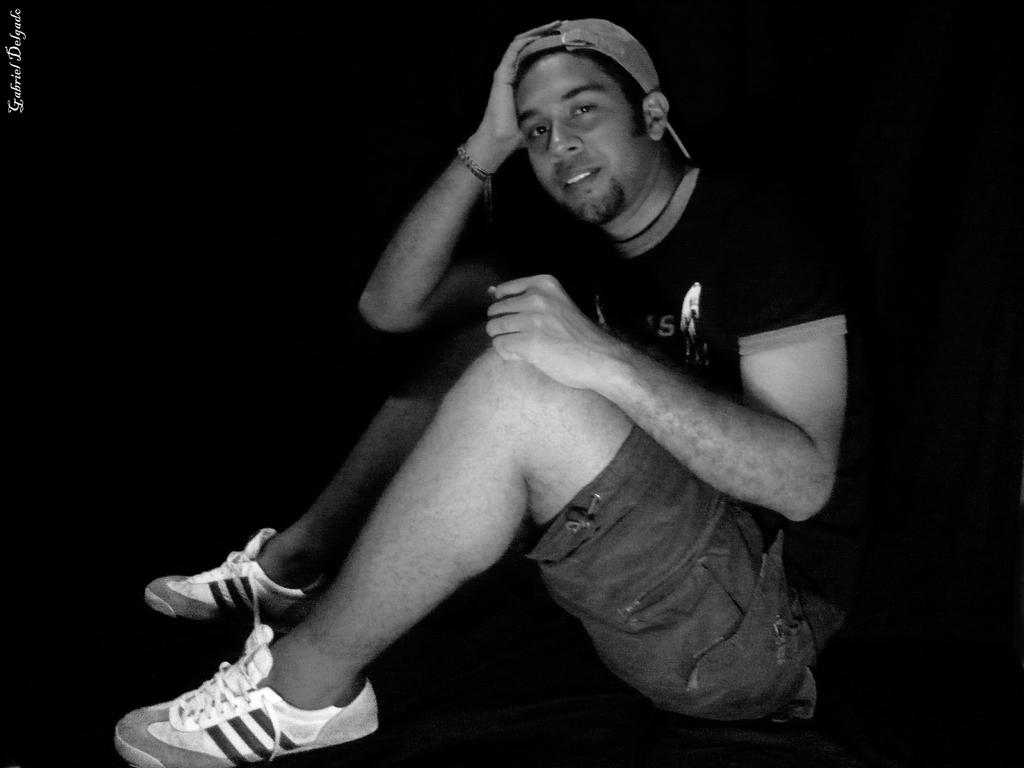What is the man in the image doing? The man is sitting in the image. What is the man wearing on his head? The man is wearing a cap. Is there any text visible in the image? Yes, there is a name in the top left corner of the image. What type of insurance does the man have for his pets in the image? There is no information about insurance or pets in the image; it only shows a man sitting and wearing a cap. 